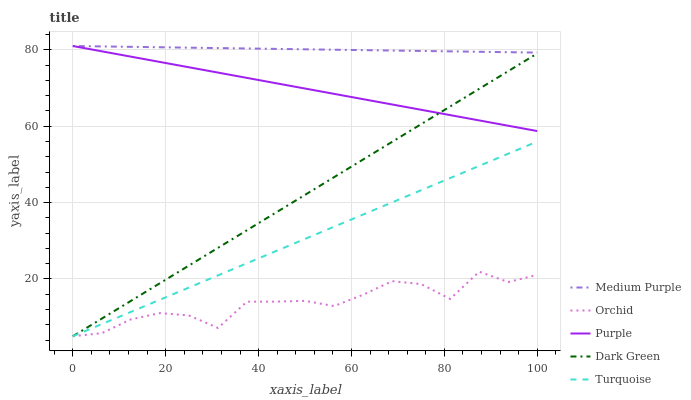Does Orchid have the minimum area under the curve?
Answer yes or no. Yes. Does Medium Purple have the maximum area under the curve?
Answer yes or no. Yes. Does Purple have the minimum area under the curve?
Answer yes or no. No. Does Purple have the maximum area under the curve?
Answer yes or no. No. Is Medium Purple the smoothest?
Answer yes or no. Yes. Is Orchid the roughest?
Answer yes or no. Yes. Is Purple the smoothest?
Answer yes or no. No. Is Purple the roughest?
Answer yes or no. No. Does Turquoise have the lowest value?
Answer yes or no. Yes. Does Purple have the lowest value?
Answer yes or no. No. Does Purple have the highest value?
Answer yes or no. Yes. Does Turquoise have the highest value?
Answer yes or no. No. Is Turquoise less than Medium Purple?
Answer yes or no. Yes. Is Medium Purple greater than Dark Green?
Answer yes or no. Yes. Does Orchid intersect Turquoise?
Answer yes or no. Yes. Is Orchid less than Turquoise?
Answer yes or no. No. Is Orchid greater than Turquoise?
Answer yes or no. No. Does Turquoise intersect Medium Purple?
Answer yes or no. No. 